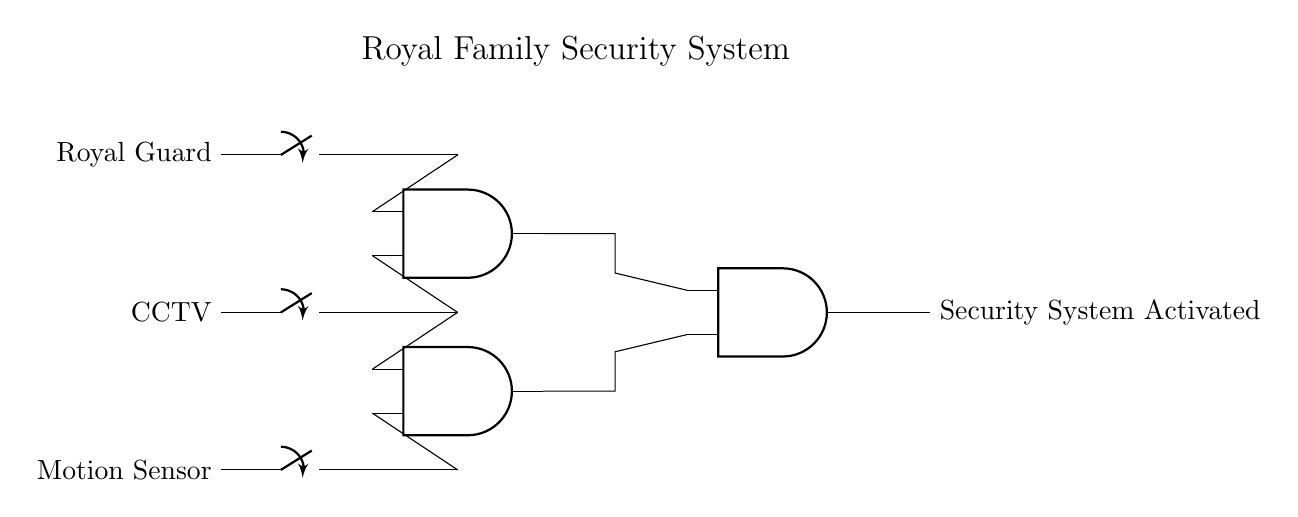What components are present in this circuit? The circuit consists of three switches representing the Royal Guard, CCTV, and Motion Sensor, and three AND gates.
Answer: Three switches and three AND gates How many AND gates are used in the circuit? The circuit diagram clearly shows three AND gates positioned at specific points within the circuit.
Answer: Three AND gates What do the switches control in this circuit? The switches control inputs from the Royal Guard, CCTV, and Motion Sensor, leading to the activation of the security system through the AND gates.
Answer: Inputs to the AND gates What must occur for the security system to be activated? The security system will only activate if all inputs to the last AND gate are HIGH, meaning all switches must be ON.
Answer: All switches must be ON What is the output of the last AND gate? The output of the last AND gate indicates whether the security system is activated based on the conditions of the inputs.
Answer: Security System Activated Which logical operation is primarily utilized in this circuit? The circuit predominantly employs the AND logical operation, as evidenced by the structure and connections of the components involved in producing the output.
Answer: AND 